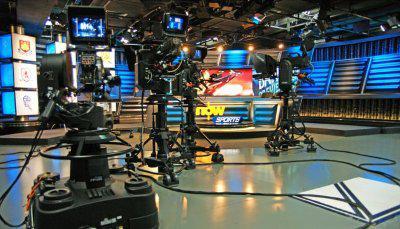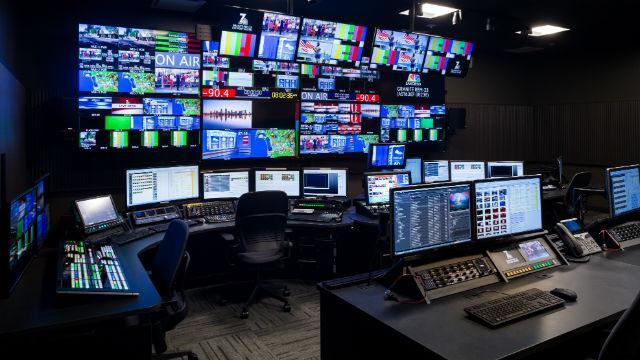The first image is the image on the left, the second image is the image on the right. For the images displayed, is the sentence "There is at least one person in the image on the left." factually correct? Answer yes or no. No. 